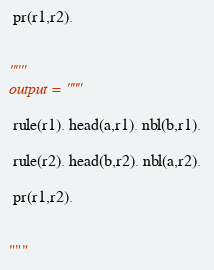Convert code to text. <code><loc_0><loc_0><loc_500><loc_500><_Python_> pr(r1,r2).


"""
output = """

 rule(r1). head(a,r1). nbl(b,r1). 

 rule(r2). head(b,r2). nbl(a,r2).

 pr(r1,r2).


"""
</code> 